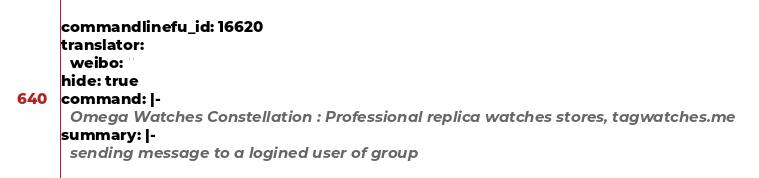<code> <loc_0><loc_0><loc_500><loc_500><_YAML_>commandlinefu_id: 16620
translator:
  weibo: ''
hide: true
command: |-
  Omega Watches Constellation : Professional replica watches stores, tagwatches.me
summary: |-
  sending message to a logined user of group
</code> 